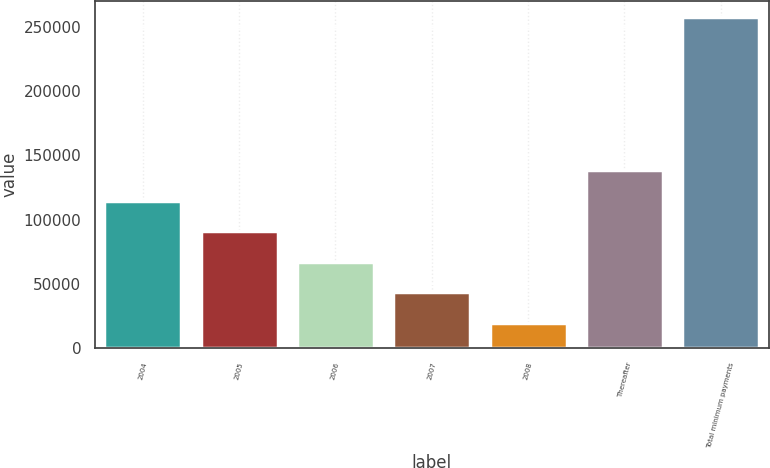Convert chart. <chart><loc_0><loc_0><loc_500><loc_500><bar_chart><fcel>2004<fcel>2005<fcel>2006<fcel>2007<fcel>2008<fcel>Thereafter<fcel>Total minimum payments<nl><fcel>114733<fcel>90980<fcel>67227<fcel>43474<fcel>19721<fcel>138486<fcel>257251<nl></chart> 